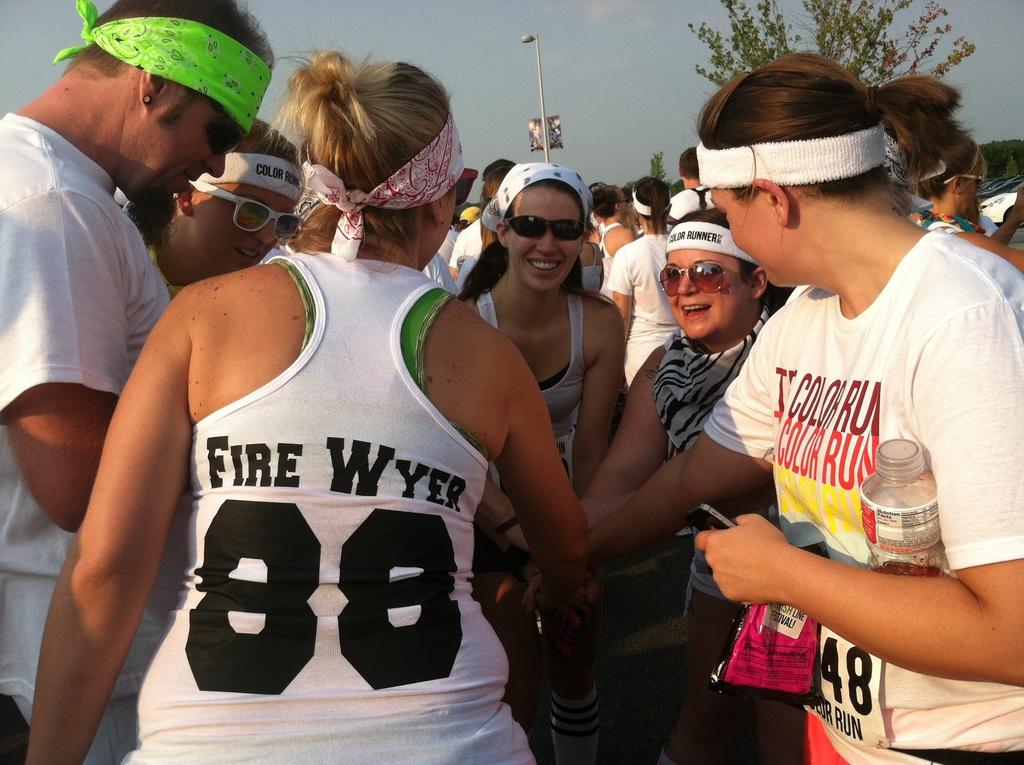What is her name?
Make the answer very short. Fire wyer. Does the man in the top left of the image have a pierced ear?
Make the answer very short. Answering does not require reading text in the image. 